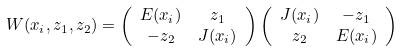<formula> <loc_0><loc_0><loc_500><loc_500>W ( x _ { i } , z _ { 1 } , z _ { 2 } ) & = \left ( \begin{array} { c c } E ( x _ { i } ) & z _ { 1 } \\ - z _ { 2 } & J ( x _ { i } ) \end{array} \right ) \left ( \begin{array} { c c } J ( x _ { i } ) & - z _ { 1 } \\ z _ { 2 } & E ( x _ { i } ) \end{array} \right )</formula> 